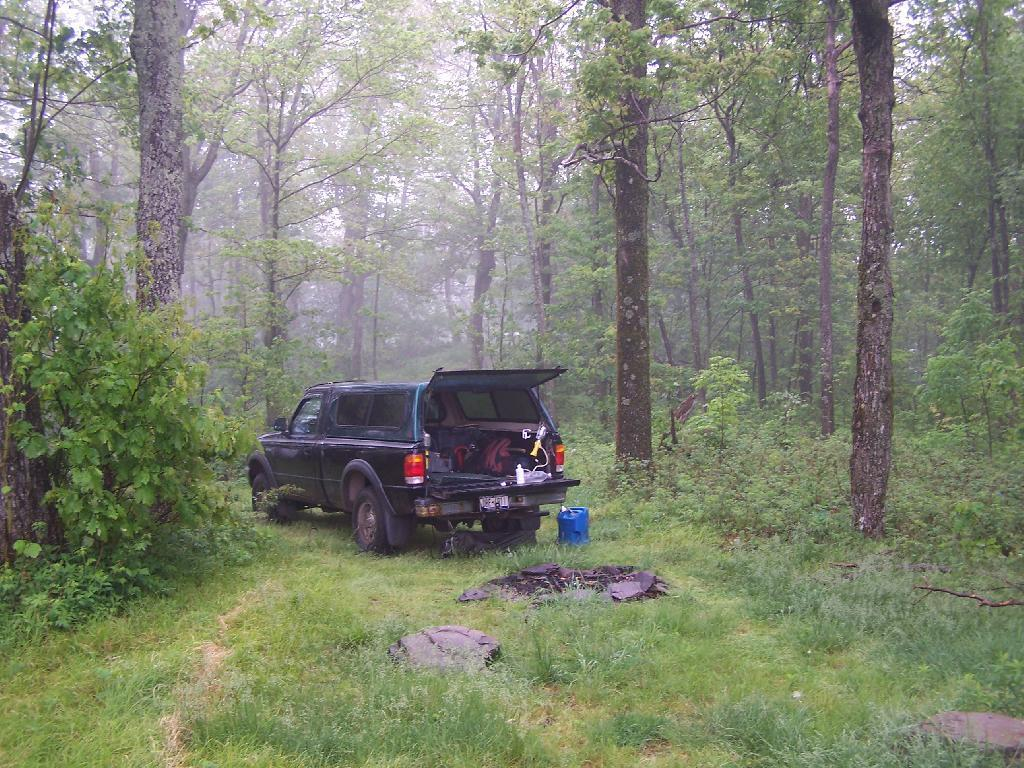What is the color of the vehicle in the image? The vehicle in the image is black. Where is the vehicle located? The vehicle is on the land. What type of vegetation is present on the ground? There is grass on the ground. What can be seen in the background of the image? There are trees and the sky visible in the background of the image. What type of creature is interacting with the vehicle in the image? There is no creature interacting with the vehicle in the image. 